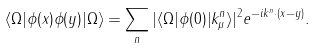Convert formula to latex. <formula><loc_0><loc_0><loc_500><loc_500>\langle \Omega | \phi ( x ) \phi ( y ) | \Omega \rangle = \sum _ { n } | \langle \Omega | \phi ( 0 ) | k ^ { n } _ { \mu } \rangle | ^ { 2 } e ^ { - i k ^ { n } \cdot ( x - y ) } .</formula> 